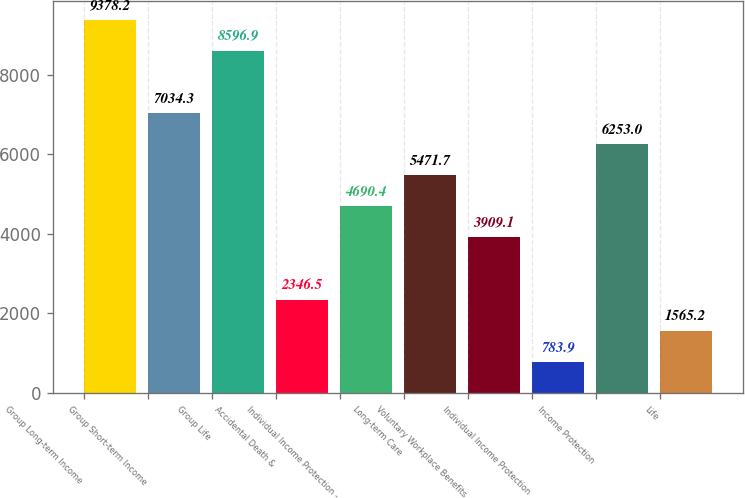Convert chart to OTSL. <chart><loc_0><loc_0><loc_500><loc_500><bar_chart><fcel>Group Long-term Income<fcel>Group Short-term Income<fcel>Group Life<fcel>Accidental Death &<fcel>Individual Income Protection -<fcel>Long-term Care<fcel>Voluntary Workplace Benefits<fcel>Individual Income Protection<fcel>Income Protection<fcel>Life<nl><fcel>9378.2<fcel>7034.3<fcel>8596.9<fcel>2346.5<fcel>4690.4<fcel>5471.7<fcel>3909.1<fcel>783.9<fcel>6253<fcel>1565.2<nl></chart> 